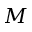<formula> <loc_0><loc_0><loc_500><loc_500>M</formula> 